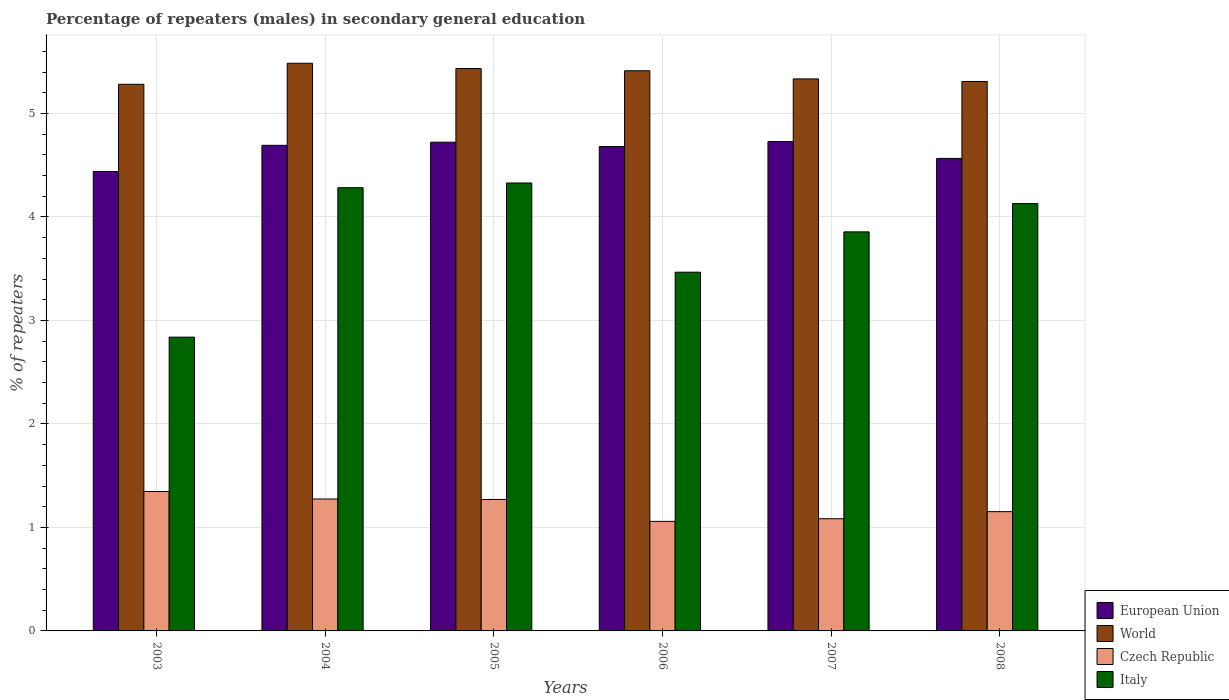Are the number of bars per tick equal to the number of legend labels?
Make the answer very short. Yes. Are the number of bars on each tick of the X-axis equal?
Your answer should be very brief. Yes. How many bars are there on the 5th tick from the left?
Provide a short and direct response. 4. In how many cases, is the number of bars for a given year not equal to the number of legend labels?
Make the answer very short. 0. What is the percentage of male repeaters in Czech Republic in 2006?
Give a very brief answer. 1.06. Across all years, what is the maximum percentage of male repeaters in Czech Republic?
Offer a very short reply. 1.35. Across all years, what is the minimum percentage of male repeaters in World?
Offer a terse response. 5.28. In which year was the percentage of male repeaters in European Union maximum?
Your answer should be compact. 2007. What is the total percentage of male repeaters in Czech Republic in the graph?
Provide a succinct answer. 7.19. What is the difference between the percentage of male repeaters in Italy in 2005 and that in 2007?
Your answer should be compact. 0.47. What is the difference between the percentage of male repeaters in World in 2005 and the percentage of male repeaters in European Union in 2006?
Your answer should be compact. 0.75. What is the average percentage of male repeaters in Czech Republic per year?
Your response must be concise. 1.2. In the year 2004, what is the difference between the percentage of male repeaters in Italy and percentage of male repeaters in European Union?
Offer a very short reply. -0.41. In how many years, is the percentage of male repeaters in European Union greater than 5.2 %?
Your response must be concise. 0. What is the ratio of the percentage of male repeaters in World in 2006 to that in 2008?
Your answer should be very brief. 1.02. Is the difference between the percentage of male repeaters in Italy in 2004 and 2008 greater than the difference between the percentage of male repeaters in European Union in 2004 and 2008?
Your response must be concise. Yes. What is the difference between the highest and the second highest percentage of male repeaters in European Union?
Ensure brevity in your answer.  0.01. What is the difference between the highest and the lowest percentage of male repeaters in European Union?
Keep it short and to the point. 0.29. Is it the case that in every year, the sum of the percentage of male repeaters in World and percentage of male repeaters in Czech Republic is greater than the sum of percentage of male repeaters in European Union and percentage of male repeaters in Italy?
Give a very brief answer. No. What does the 3rd bar from the left in 2005 represents?
Provide a succinct answer. Czech Republic. What does the 2nd bar from the right in 2004 represents?
Keep it short and to the point. Czech Republic. Is it the case that in every year, the sum of the percentage of male repeaters in World and percentage of male repeaters in Italy is greater than the percentage of male repeaters in Czech Republic?
Your answer should be very brief. Yes. Are all the bars in the graph horizontal?
Your response must be concise. No. How many years are there in the graph?
Provide a succinct answer. 6. What is the difference between two consecutive major ticks on the Y-axis?
Make the answer very short. 1. Are the values on the major ticks of Y-axis written in scientific E-notation?
Provide a succinct answer. No. Does the graph contain any zero values?
Offer a very short reply. No. How are the legend labels stacked?
Make the answer very short. Vertical. What is the title of the graph?
Your answer should be compact. Percentage of repeaters (males) in secondary general education. Does "Sudan" appear as one of the legend labels in the graph?
Keep it short and to the point. No. What is the label or title of the X-axis?
Provide a short and direct response. Years. What is the label or title of the Y-axis?
Give a very brief answer. % of repeaters. What is the % of repeaters of European Union in 2003?
Provide a short and direct response. 4.44. What is the % of repeaters of World in 2003?
Offer a terse response. 5.28. What is the % of repeaters of Czech Republic in 2003?
Give a very brief answer. 1.35. What is the % of repeaters in Italy in 2003?
Your answer should be very brief. 2.84. What is the % of repeaters in European Union in 2004?
Ensure brevity in your answer.  4.69. What is the % of repeaters of World in 2004?
Your answer should be very brief. 5.48. What is the % of repeaters of Czech Republic in 2004?
Your answer should be very brief. 1.27. What is the % of repeaters of Italy in 2004?
Provide a succinct answer. 4.28. What is the % of repeaters in European Union in 2005?
Give a very brief answer. 4.72. What is the % of repeaters in World in 2005?
Give a very brief answer. 5.43. What is the % of repeaters of Czech Republic in 2005?
Your response must be concise. 1.27. What is the % of repeaters in Italy in 2005?
Offer a very short reply. 4.33. What is the % of repeaters in European Union in 2006?
Your response must be concise. 4.68. What is the % of repeaters in World in 2006?
Your response must be concise. 5.41. What is the % of repeaters in Czech Republic in 2006?
Keep it short and to the point. 1.06. What is the % of repeaters in Italy in 2006?
Give a very brief answer. 3.47. What is the % of repeaters in European Union in 2007?
Your answer should be compact. 4.73. What is the % of repeaters of World in 2007?
Your answer should be compact. 5.33. What is the % of repeaters of Czech Republic in 2007?
Your answer should be very brief. 1.08. What is the % of repeaters of Italy in 2007?
Offer a terse response. 3.86. What is the % of repeaters in European Union in 2008?
Your response must be concise. 4.57. What is the % of repeaters of World in 2008?
Your answer should be compact. 5.31. What is the % of repeaters of Czech Republic in 2008?
Give a very brief answer. 1.15. What is the % of repeaters of Italy in 2008?
Provide a succinct answer. 4.13. Across all years, what is the maximum % of repeaters in European Union?
Make the answer very short. 4.73. Across all years, what is the maximum % of repeaters of World?
Offer a terse response. 5.48. Across all years, what is the maximum % of repeaters of Czech Republic?
Give a very brief answer. 1.35. Across all years, what is the maximum % of repeaters in Italy?
Your answer should be very brief. 4.33. Across all years, what is the minimum % of repeaters in European Union?
Make the answer very short. 4.44. Across all years, what is the minimum % of repeaters in World?
Make the answer very short. 5.28. Across all years, what is the minimum % of repeaters in Czech Republic?
Provide a short and direct response. 1.06. Across all years, what is the minimum % of repeaters of Italy?
Keep it short and to the point. 2.84. What is the total % of repeaters in European Union in the graph?
Provide a short and direct response. 27.83. What is the total % of repeaters of World in the graph?
Offer a terse response. 32.26. What is the total % of repeaters in Czech Republic in the graph?
Your response must be concise. 7.19. What is the total % of repeaters in Italy in the graph?
Give a very brief answer. 22.9. What is the difference between the % of repeaters in European Union in 2003 and that in 2004?
Make the answer very short. -0.25. What is the difference between the % of repeaters in World in 2003 and that in 2004?
Keep it short and to the point. -0.2. What is the difference between the % of repeaters in Czech Republic in 2003 and that in 2004?
Offer a terse response. 0.07. What is the difference between the % of repeaters of Italy in 2003 and that in 2004?
Your answer should be compact. -1.44. What is the difference between the % of repeaters in European Union in 2003 and that in 2005?
Provide a short and direct response. -0.28. What is the difference between the % of repeaters in World in 2003 and that in 2005?
Ensure brevity in your answer.  -0.15. What is the difference between the % of repeaters in Czech Republic in 2003 and that in 2005?
Offer a terse response. 0.08. What is the difference between the % of repeaters in Italy in 2003 and that in 2005?
Your answer should be very brief. -1.49. What is the difference between the % of repeaters in European Union in 2003 and that in 2006?
Ensure brevity in your answer.  -0.24. What is the difference between the % of repeaters of World in 2003 and that in 2006?
Ensure brevity in your answer.  -0.13. What is the difference between the % of repeaters in Czech Republic in 2003 and that in 2006?
Make the answer very short. 0.29. What is the difference between the % of repeaters in Italy in 2003 and that in 2006?
Provide a succinct answer. -0.63. What is the difference between the % of repeaters in European Union in 2003 and that in 2007?
Give a very brief answer. -0.29. What is the difference between the % of repeaters of World in 2003 and that in 2007?
Keep it short and to the point. -0.05. What is the difference between the % of repeaters in Czech Republic in 2003 and that in 2007?
Offer a very short reply. 0.26. What is the difference between the % of repeaters in Italy in 2003 and that in 2007?
Your response must be concise. -1.02. What is the difference between the % of repeaters in European Union in 2003 and that in 2008?
Provide a short and direct response. -0.13. What is the difference between the % of repeaters of World in 2003 and that in 2008?
Your answer should be compact. -0.03. What is the difference between the % of repeaters in Czech Republic in 2003 and that in 2008?
Offer a very short reply. 0.19. What is the difference between the % of repeaters of Italy in 2003 and that in 2008?
Keep it short and to the point. -1.29. What is the difference between the % of repeaters in European Union in 2004 and that in 2005?
Provide a short and direct response. -0.03. What is the difference between the % of repeaters of World in 2004 and that in 2005?
Offer a very short reply. 0.05. What is the difference between the % of repeaters of Czech Republic in 2004 and that in 2005?
Make the answer very short. 0. What is the difference between the % of repeaters of Italy in 2004 and that in 2005?
Offer a terse response. -0.05. What is the difference between the % of repeaters of European Union in 2004 and that in 2006?
Make the answer very short. 0.01. What is the difference between the % of repeaters in World in 2004 and that in 2006?
Offer a very short reply. 0.07. What is the difference between the % of repeaters in Czech Republic in 2004 and that in 2006?
Make the answer very short. 0.22. What is the difference between the % of repeaters in Italy in 2004 and that in 2006?
Make the answer very short. 0.82. What is the difference between the % of repeaters of European Union in 2004 and that in 2007?
Your answer should be compact. -0.04. What is the difference between the % of repeaters in World in 2004 and that in 2007?
Offer a very short reply. 0.15. What is the difference between the % of repeaters of Czech Republic in 2004 and that in 2007?
Your answer should be very brief. 0.19. What is the difference between the % of repeaters in Italy in 2004 and that in 2007?
Give a very brief answer. 0.43. What is the difference between the % of repeaters of European Union in 2004 and that in 2008?
Make the answer very short. 0.13. What is the difference between the % of repeaters in World in 2004 and that in 2008?
Provide a succinct answer. 0.18. What is the difference between the % of repeaters in Czech Republic in 2004 and that in 2008?
Make the answer very short. 0.12. What is the difference between the % of repeaters in Italy in 2004 and that in 2008?
Your answer should be compact. 0.15. What is the difference between the % of repeaters in European Union in 2005 and that in 2006?
Give a very brief answer. 0.04. What is the difference between the % of repeaters in World in 2005 and that in 2006?
Offer a very short reply. 0.02. What is the difference between the % of repeaters in Czech Republic in 2005 and that in 2006?
Your answer should be very brief. 0.21. What is the difference between the % of repeaters of Italy in 2005 and that in 2006?
Your answer should be very brief. 0.86. What is the difference between the % of repeaters in European Union in 2005 and that in 2007?
Provide a succinct answer. -0.01. What is the difference between the % of repeaters of World in 2005 and that in 2007?
Make the answer very short. 0.1. What is the difference between the % of repeaters of Czech Republic in 2005 and that in 2007?
Provide a short and direct response. 0.19. What is the difference between the % of repeaters of Italy in 2005 and that in 2007?
Offer a very short reply. 0.47. What is the difference between the % of repeaters in European Union in 2005 and that in 2008?
Keep it short and to the point. 0.16. What is the difference between the % of repeaters in World in 2005 and that in 2008?
Keep it short and to the point. 0.13. What is the difference between the % of repeaters in Czech Republic in 2005 and that in 2008?
Offer a terse response. 0.12. What is the difference between the % of repeaters of Italy in 2005 and that in 2008?
Keep it short and to the point. 0.2. What is the difference between the % of repeaters of European Union in 2006 and that in 2007?
Your response must be concise. -0.05. What is the difference between the % of repeaters in World in 2006 and that in 2007?
Offer a terse response. 0.08. What is the difference between the % of repeaters in Czech Republic in 2006 and that in 2007?
Your answer should be compact. -0.03. What is the difference between the % of repeaters in Italy in 2006 and that in 2007?
Provide a succinct answer. -0.39. What is the difference between the % of repeaters of European Union in 2006 and that in 2008?
Your answer should be compact. 0.11. What is the difference between the % of repeaters in World in 2006 and that in 2008?
Give a very brief answer. 0.1. What is the difference between the % of repeaters of Czech Republic in 2006 and that in 2008?
Your response must be concise. -0.09. What is the difference between the % of repeaters in Italy in 2006 and that in 2008?
Your answer should be compact. -0.66. What is the difference between the % of repeaters of European Union in 2007 and that in 2008?
Your answer should be compact. 0.16. What is the difference between the % of repeaters in World in 2007 and that in 2008?
Offer a terse response. 0.03. What is the difference between the % of repeaters of Czech Republic in 2007 and that in 2008?
Your response must be concise. -0.07. What is the difference between the % of repeaters in Italy in 2007 and that in 2008?
Provide a short and direct response. -0.27. What is the difference between the % of repeaters in European Union in 2003 and the % of repeaters in World in 2004?
Give a very brief answer. -1.05. What is the difference between the % of repeaters in European Union in 2003 and the % of repeaters in Czech Republic in 2004?
Provide a short and direct response. 3.16. What is the difference between the % of repeaters of European Union in 2003 and the % of repeaters of Italy in 2004?
Make the answer very short. 0.16. What is the difference between the % of repeaters in World in 2003 and the % of repeaters in Czech Republic in 2004?
Provide a succinct answer. 4.01. What is the difference between the % of repeaters in World in 2003 and the % of repeaters in Italy in 2004?
Offer a terse response. 1. What is the difference between the % of repeaters of Czech Republic in 2003 and the % of repeaters of Italy in 2004?
Ensure brevity in your answer.  -2.94. What is the difference between the % of repeaters in European Union in 2003 and the % of repeaters in World in 2005?
Provide a short and direct response. -1. What is the difference between the % of repeaters in European Union in 2003 and the % of repeaters in Czech Republic in 2005?
Ensure brevity in your answer.  3.17. What is the difference between the % of repeaters in European Union in 2003 and the % of repeaters in Italy in 2005?
Your answer should be compact. 0.11. What is the difference between the % of repeaters of World in 2003 and the % of repeaters of Czech Republic in 2005?
Provide a succinct answer. 4.01. What is the difference between the % of repeaters in World in 2003 and the % of repeaters in Italy in 2005?
Your answer should be very brief. 0.95. What is the difference between the % of repeaters in Czech Republic in 2003 and the % of repeaters in Italy in 2005?
Provide a succinct answer. -2.98. What is the difference between the % of repeaters of European Union in 2003 and the % of repeaters of World in 2006?
Offer a very short reply. -0.97. What is the difference between the % of repeaters in European Union in 2003 and the % of repeaters in Czech Republic in 2006?
Give a very brief answer. 3.38. What is the difference between the % of repeaters in European Union in 2003 and the % of repeaters in Italy in 2006?
Your answer should be compact. 0.97. What is the difference between the % of repeaters of World in 2003 and the % of repeaters of Czech Republic in 2006?
Offer a terse response. 4.22. What is the difference between the % of repeaters of World in 2003 and the % of repeaters of Italy in 2006?
Your answer should be very brief. 1.82. What is the difference between the % of repeaters of Czech Republic in 2003 and the % of repeaters of Italy in 2006?
Your answer should be very brief. -2.12. What is the difference between the % of repeaters of European Union in 2003 and the % of repeaters of World in 2007?
Provide a short and direct response. -0.89. What is the difference between the % of repeaters of European Union in 2003 and the % of repeaters of Czech Republic in 2007?
Your response must be concise. 3.35. What is the difference between the % of repeaters of European Union in 2003 and the % of repeaters of Italy in 2007?
Give a very brief answer. 0.58. What is the difference between the % of repeaters of World in 2003 and the % of repeaters of Czech Republic in 2007?
Your answer should be very brief. 4.2. What is the difference between the % of repeaters of World in 2003 and the % of repeaters of Italy in 2007?
Your response must be concise. 1.43. What is the difference between the % of repeaters in Czech Republic in 2003 and the % of repeaters in Italy in 2007?
Provide a short and direct response. -2.51. What is the difference between the % of repeaters of European Union in 2003 and the % of repeaters of World in 2008?
Your answer should be compact. -0.87. What is the difference between the % of repeaters in European Union in 2003 and the % of repeaters in Czech Republic in 2008?
Give a very brief answer. 3.29. What is the difference between the % of repeaters of European Union in 2003 and the % of repeaters of Italy in 2008?
Offer a very short reply. 0.31. What is the difference between the % of repeaters in World in 2003 and the % of repeaters in Czech Republic in 2008?
Offer a terse response. 4.13. What is the difference between the % of repeaters in World in 2003 and the % of repeaters in Italy in 2008?
Make the answer very short. 1.15. What is the difference between the % of repeaters of Czech Republic in 2003 and the % of repeaters of Italy in 2008?
Your answer should be very brief. -2.78. What is the difference between the % of repeaters of European Union in 2004 and the % of repeaters of World in 2005?
Keep it short and to the point. -0.74. What is the difference between the % of repeaters of European Union in 2004 and the % of repeaters of Czech Republic in 2005?
Provide a succinct answer. 3.42. What is the difference between the % of repeaters in European Union in 2004 and the % of repeaters in Italy in 2005?
Provide a succinct answer. 0.36. What is the difference between the % of repeaters in World in 2004 and the % of repeaters in Czech Republic in 2005?
Ensure brevity in your answer.  4.21. What is the difference between the % of repeaters in World in 2004 and the % of repeaters in Italy in 2005?
Your answer should be compact. 1.16. What is the difference between the % of repeaters of Czech Republic in 2004 and the % of repeaters of Italy in 2005?
Provide a succinct answer. -3.05. What is the difference between the % of repeaters of European Union in 2004 and the % of repeaters of World in 2006?
Your answer should be very brief. -0.72. What is the difference between the % of repeaters of European Union in 2004 and the % of repeaters of Czech Republic in 2006?
Ensure brevity in your answer.  3.63. What is the difference between the % of repeaters in European Union in 2004 and the % of repeaters in Italy in 2006?
Keep it short and to the point. 1.23. What is the difference between the % of repeaters of World in 2004 and the % of repeaters of Czech Republic in 2006?
Your answer should be compact. 4.43. What is the difference between the % of repeaters of World in 2004 and the % of repeaters of Italy in 2006?
Give a very brief answer. 2.02. What is the difference between the % of repeaters of Czech Republic in 2004 and the % of repeaters of Italy in 2006?
Your response must be concise. -2.19. What is the difference between the % of repeaters of European Union in 2004 and the % of repeaters of World in 2007?
Give a very brief answer. -0.64. What is the difference between the % of repeaters of European Union in 2004 and the % of repeaters of Czech Republic in 2007?
Offer a terse response. 3.61. What is the difference between the % of repeaters in European Union in 2004 and the % of repeaters in Italy in 2007?
Give a very brief answer. 0.84. What is the difference between the % of repeaters of World in 2004 and the % of repeaters of Czech Republic in 2007?
Your answer should be compact. 4.4. What is the difference between the % of repeaters in World in 2004 and the % of repeaters in Italy in 2007?
Provide a short and direct response. 1.63. What is the difference between the % of repeaters of Czech Republic in 2004 and the % of repeaters of Italy in 2007?
Keep it short and to the point. -2.58. What is the difference between the % of repeaters of European Union in 2004 and the % of repeaters of World in 2008?
Offer a very short reply. -0.62. What is the difference between the % of repeaters of European Union in 2004 and the % of repeaters of Czech Republic in 2008?
Make the answer very short. 3.54. What is the difference between the % of repeaters of European Union in 2004 and the % of repeaters of Italy in 2008?
Provide a succinct answer. 0.56. What is the difference between the % of repeaters in World in 2004 and the % of repeaters in Czech Republic in 2008?
Keep it short and to the point. 4.33. What is the difference between the % of repeaters in World in 2004 and the % of repeaters in Italy in 2008?
Keep it short and to the point. 1.36. What is the difference between the % of repeaters in Czech Republic in 2004 and the % of repeaters in Italy in 2008?
Ensure brevity in your answer.  -2.85. What is the difference between the % of repeaters of European Union in 2005 and the % of repeaters of World in 2006?
Provide a succinct answer. -0.69. What is the difference between the % of repeaters of European Union in 2005 and the % of repeaters of Czech Republic in 2006?
Ensure brevity in your answer.  3.66. What is the difference between the % of repeaters of European Union in 2005 and the % of repeaters of Italy in 2006?
Offer a very short reply. 1.26. What is the difference between the % of repeaters in World in 2005 and the % of repeaters in Czech Republic in 2006?
Make the answer very short. 4.38. What is the difference between the % of repeaters of World in 2005 and the % of repeaters of Italy in 2006?
Ensure brevity in your answer.  1.97. What is the difference between the % of repeaters of Czech Republic in 2005 and the % of repeaters of Italy in 2006?
Provide a short and direct response. -2.2. What is the difference between the % of repeaters of European Union in 2005 and the % of repeaters of World in 2007?
Make the answer very short. -0.61. What is the difference between the % of repeaters of European Union in 2005 and the % of repeaters of Czech Republic in 2007?
Make the answer very short. 3.64. What is the difference between the % of repeaters of European Union in 2005 and the % of repeaters of Italy in 2007?
Offer a terse response. 0.87. What is the difference between the % of repeaters in World in 2005 and the % of repeaters in Czech Republic in 2007?
Provide a short and direct response. 4.35. What is the difference between the % of repeaters in World in 2005 and the % of repeaters in Italy in 2007?
Your answer should be very brief. 1.58. What is the difference between the % of repeaters in Czech Republic in 2005 and the % of repeaters in Italy in 2007?
Give a very brief answer. -2.59. What is the difference between the % of repeaters of European Union in 2005 and the % of repeaters of World in 2008?
Make the answer very short. -0.59. What is the difference between the % of repeaters of European Union in 2005 and the % of repeaters of Czech Republic in 2008?
Provide a succinct answer. 3.57. What is the difference between the % of repeaters in European Union in 2005 and the % of repeaters in Italy in 2008?
Your response must be concise. 0.59. What is the difference between the % of repeaters of World in 2005 and the % of repeaters of Czech Republic in 2008?
Give a very brief answer. 4.28. What is the difference between the % of repeaters in World in 2005 and the % of repeaters in Italy in 2008?
Offer a terse response. 1.31. What is the difference between the % of repeaters in Czech Republic in 2005 and the % of repeaters in Italy in 2008?
Ensure brevity in your answer.  -2.86. What is the difference between the % of repeaters in European Union in 2006 and the % of repeaters in World in 2007?
Provide a succinct answer. -0.65. What is the difference between the % of repeaters in European Union in 2006 and the % of repeaters in Czech Republic in 2007?
Your answer should be very brief. 3.6. What is the difference between the % of repeaters in European Union in 2006 and the % of repeaters in Italy in 2007?
Ensure brevity in your answer.  0.82. What is the difference between the % of repeaters in World in 2006 and the % of repeaters in Czech Republic in 2007?
Provide a short and direct response. 4.33. What is the difference between the % of repeaters of World in 2006 and the % of repeaters of Italy in 2007?
Provide a succinct answer. 1.56. What is the difference between the % of repeaters in Czech Republic in 2006 and the % of repeaters in Italy in 2007?
Keep it short and to the point. -2.8. What is the difference between the % of repeaters of European Union in 2006 and the % of repeaters of World in 2008?
Ensure brevity in your answer.  -0.63. What is the difference between the % of repeaters of European Union in 2006 and the % of repeaters of Czech Republic in 2008?
Make the answer very short. 3.53. What is the difference between the % of repeaters of European Union in 2006 and the % of repeaters of Italy in 2008?
Ensure brevity in your answer.  0.55. What is the difference between the % of repeaters of World in 2006 and the % of repeaters of Czech Republic in 2008?
Keep it short and to the point. 4.26. What is the difference between the % of repeaters in World in 2006 and the % of repeaters in Italy in 2008?
Provide a short and direct response. 1.28. What is the difference between the % of repeaters of Czech Republic in 2006 and the % of repeaters of Italy in 2008?
Your answer should be compact. -3.07. What is the difference between the % of repeaters of European Union in 2007 and the % of repeaters of World in 2008?
Make the answer very short. -0.58. What is the difference between the % of repeaters in European Union in 2007 and the % of repeaters in Czech Republic in 2008?
Ensure brevity in your answer.  3.58. What is the difference between the % of repeaters in European Union in 2007 and the % of repeaters in Italy in 2008?
Your answer should be compact. 0.6. What is the difference between the % of repeaters of World in 2007 and the % of repeaters of Czech Republic in 2008?
Provide a succinct answer. 4.18. What is the difference between the % of repeaters of World in 2007 and the % of repeaters of Italy in 2008?
Offer a very short reply. 1.2. What is the difference between the % of repeaters of Czech Republic in 2007 and the % of repeaters of Italy in 2008?
Offer a terse response. -3.04. What is the average % of repeaters in European Union per year?
Keep it short and to the point. 4.64. What is the average % of repeaters of World per year?
Offer a very short reply. 5.38. What is the average % of repeaters in Czech Republic per year?
Offer a terse response. 1.2. What is the average % of repeaters of Italy per year?
Your response must be concise. 3.82. In the year 2003, what is the difference between the % of repeaters in European Union and % of repeaters in World?
Keep it short and to the point. -0.84. In the year 2003, what is the difference between the % of repeaters in European Union and % of repeaters in Czech Republic?
Give a very brief answer. 3.09. In the year 2003, what is the difference between the % of repeaters in European Union and % of repeaters in Italy?
Offer a terse response. 1.6. In the year 2003, what is the difference between the % of repeaters in World and % of repeaters in Czech Republic?
Give a very brief answer. 3.93. In the year 2003, what is the difference between the % of repeaters in World and % of repeaters in Italy?
Give a very brief answer. 2.44. In the year 2003, what is the difference between the % of repeaters in Czech Republic and % of repeaters in Italy?
Give a very brief answer. -1.49. In the year 2004, what is the difference between the % of repeaters of European Union and % of repeaters of World?
Keep it short and to the point. -0.79. In the year 2004, what is the difference between the % of repeaters in European Union and % of repeaters in Czech Republic?
Offer a terse response. 3.42. In the year 2004, what is the difference between the % of repeaters in European Union and % of repeaters in Italy?
Offer a very short reply. 0.41. In the year 2004, what is the difference between the % of repeaters in World and % of repeaters in Czech Republic?
Offer a terse response. 4.21. In the year 2004, what is the difference between the % of repeaters of World and % of repeaters of Italy?
Make the answer very short. 1.2. In the year 2004, what is the difference between the % of repeaters in Czech Republic and % of repeaters in Italy?
Offer a very short reply. -3.01. In the year 2005, what is the difference between the % of repeaters in European Union and % of repeaters in World?
Give a very brief answer. -0.71. In the year 2005, what is the difference between the % of repeaters in European Union and % of repeaters in Czech Republic?
Ensure brevity in your answer.  3.45. In the year 2005, what is the difference between the % of repeaters of European Union and % of repeaters of Italy?
Offer a very short reply. 0.39. In the year 2005, what is the difference between the % of repeaters in World and % of repeaters in Czech Republic?
Make the answer very short. 4.16. In the year 2005, what is the difference between the % of repeaters in World and % of repeaters in Italy?
Your answer should be very brief. 1.11. In the year 2005, what is the difference between the % of repeaters of Czech Republic and % of repeaters of Italy?
Give a very brief answer. -3.06. In the year 2006, what is the difference between the % of repeaters in European Union and % of repeaters in World?
Offer a terse response. -0.73. In the year 2006, what is the difference between the % of repeaters of European Union and % of repeaters of Czech Republic?
Offer a terse response. 3.62. In the year 2006, what is the difference between the % of repeaters of European Union and % of repeaters of Italy?
Your answer should be very brief. 1.21. In the year 2006, what is the difference between the % of repeaters in World and % of repeaters in Czech Republic?
Make the answer very short. 4.35. In the year 2006, what is the difference between the % of repeaters in World and % of repeaters in Italy?
Make the answer very short. 1.95. In the year 2006, what is the difference between the % of repeaters of Czech Republic and % of repeaters of Italy?
Ensure brevity in your answer.  -2.41. In the year 2007, what is the difference between the % of repeaters in European Union and % of repeaters in World?
Your response must be concise. -0.61. In the year 2007, what is the difference between the % of repeaters of European Union and % of repeaters of Czech Republic?
Provide a succinct answer. 3.64. In the year 2007, what is the difference between the % of repeaters in European Union and % of repeaters in Italy?
Your response must be concise. 0.87. In the year 2007, what is the difference between the % of repeaters of World and % of repeaters of Czech Republic?
Give a very brief answer. 4.25. In the year 2007, what is the difference between the % of repeaters in World and % of repeaters in Italy?
Offer a terse response. 1.48. In the year 2007, what is the difference between the % of repeaters of Czech Republic and % of repeaters of Italy?
Make the answer very short. -2.77. In the year 2008, what is the difference between the % of repeaters of European Union and % of repeaters of World?
Your answer should be compact. -0.74. In the year 2008, what is the difference between the % of repeaters in European Union and % of repeaters in Czech Republic?
Provide a short and direct response. 3.41. In the year 2008, what is the difference between the % of repeaters of European Union and % of repeaters of Italy?
Your response must be concise. 0.44. In the year 2008, what is the difference between the % of repeaters in World and % of repeaters in Czech Republic?
Offer a terse response. 4.16. In the year 2008, what is the difference between the % of repeaters of World and % of repeaters of Italy?
Your response must be concise. 1.18. In the year 2008, what is the difference between the % of repeaters in Czech Republic and % of repeaters in Italy?
Keep it short and to the point. -2.98. What is the ratio of the % of repeaters of European Union in 2003 to that in 2004?
Keep it short and to the point. 0.95. What is the ratio of the % of repeaters of World in 2003 to that in 2004?
Your answer should be very brief. 0.96. What is the ratio of the % of repeaters of Czech Republic in 2003 to that in 2004?
Your answer should be very brief. 1.06. What is the ratio of the % of repeaters in Italy in 2003 to that in 2004?
Keep it short and to the point. 0.66. What is the ratio of the % of repeaters of European Union in 2003 to that in 2005?
Provide a short and direct response. 0.94. What is the ratio of the % of repeaters in World in 2003 to that in 2005?
Keep it short and to the point. 0.97. What is the ratio of the % of repeaters of Czech Republic in 2003 to that in 2005?
Offer a very short reply. 1.06. What is the ratio of the % of repeaters in Italy in 2003 to that in 2005?
Give a very brief answer. 0.66. What is the ratio of the % of repeaters of European Union in 2003 to that in 2006?
Provide a short and direct response. 0.95. What is the ratio of the % of repeaters of World in 2003 to that in 2006?
Your answer should be very brief. 0.98. What is the ratio of the % of repeaters of Czech Republic in 2003 to that in 2006?
Your response must be concise. 1.27. What is the ratio of the % of repeaters of Italy in 2003 to that in 2006?
Provide a short and direct response. 0.82. What is the ratio of the % of repeaters of European Union in 2003 to that in 2007?
Ensure brevity in your answer.  0.94. What is the ratio of the % of repeaters in World in 2003 to that in 2007?
Your response must be concise. 0.99. What is the ratio of the % of repeaters in Czech Republic in 2003 to that in 2007?
Provide a succinct answer. 1.24. What is the ratio of the % of repeaters in Italy in 2003 to that in 2007?
Your answer should be very brief. 0.74. What is the ratio of the % of repeaters of European Union in 2003 to that in 2008?
Ensure brevity in your answer.  0.97. What is the ratio of the % of repeaters of Czech Republic in 2003 to that in 2008?
Offer a very short reply. 1.17. What is the ratio of the % of repeaters of Italy in 2003 to that in 2008?
Your answer should be very brief. 0.69. What is the ratio of the % of repeaters of European Union in 2004 to that in 2005?
Make the answer very short. 0.99. What is the ratio of the % of repeaters in World in 2004 to that in 2005?
Ensure brevity in your answer.  1.01. What is the ratio of the % of repeaters of Italy in 2004 to that in 2005?
Ensure brevity in your answer.  0.99. What is the ratio of the % of repeaters of World in 2004 to that in 2006?
Your answer should be compact. 1.01. What is the ratio of the % of repeaters of Czech Republic in 2004 to that in 2006?
Keep it short and to the point. 1.2. What is the ratio of the % of repeaters of Italy in 2004 to that in 2006?
Provide a succinct answer. 1.24. What is the ratio of the % of repeaters in World in 2004 to that in 2007?
Offer a very short reply. 1.03. What is the ratio of the % of repeaters in Czech Republic in 2004 to that in 2007?
Your answer should be very brief. 1.18. What is the ratio of the % of repeaters in Italy in 2004 to that in 2007?
Your answer should be very brief. 1.11. What is the ratio of the % of repeaters of European Union in 2004 to that in 2008?
Provide a succinct answer. 1.03. What is the ratio of the % of repeaters of World in 2004 to that in 2008?
Ensure brevity in your answer.  1.03. What is the ratio of the % of repeaters in Czech Republic in 2004 to that in 2008?
Give a very brief answer. 1.11. What is the ratio of the % of repeaters of Italy in 2004 to that in 2008?
Keep it short and to the point. 1.04. What is the ratio of the % of repeaters in European Union in 2005 to that in 2006?
Offer a terse response. 1.01. What is the ratio of the % of repeaters in World in 2005 to that in 2006?
Your answer should be compact. 1. What is the ratio of the % of repeaters in Czech Republic in 2005 to that in 2006?
Provide a succinct answer. 1.2. What is the ratio of the % of repeaters of Italy in 2005 to that in 2006?
Give a very brief answer. 1.25. What is the ratio of the % of repeaters of World in 2005 to that in 2007?
Your answer should be very brief. 1.02. What is the ratio of the % of repeaters in Czech Republic in 2005 to that in 2007?
Keep it short and to the point. 1.17. What is the ratio of the % of repeaters of Italy in 2005 to that in 2007?
Ensure brevity in your answer.  1.12. What is the ratio of the % of repeaters of European Union in 2005 to that in 2008?
Offer a very short reply. 1.03. What is the ratio of the % of repeaters in World in 2005 to that in 2008?
Your answer should be compact. 1.02. What is the ratio of the % of repeaters of Czech Republic in 2005 to that in 2008?
Ensure brevity in your answer.  1.1. What is the ratio of the % of repeaters of Italy in 2005 to that in 2008?
Give a very brief answer. 1.05. What is the ratio of the % of repeaters of World in 2006 to that in 2007?
Keep it short and to the point. 1.01. What is the ratio of the % of repeaters in Czech Republic in 2006 to that in 2007?
Offer a very short reply. 0.98. What is the ratio of the % of repeaters in Italy in 2006 to that in 2007?
Provide a short and direct response. 0.9. What is the ratio of the % of repeaters of European Union in 2006 to that in 2008?
Your answer should be very brief. 1.03. What is the ratio of the % of repeaters in World in 2006 to that in 2008?
Provide a short and direct response. 1.02. What is the ratio of the % of repeaters in Czech Republic in 2006 to that in 2008?
Your answer should be very brief. 0.92. What is the ratio of the % of repeaters in Italy in 2006 to that in 2008?
Ensure brevity in your answer.  0.84. What is the ratio of the % of repeaters in European Union in 2007 to that in 2008?
Offer a very short reply. 1.04. What is the ratio of the % of repeaters of Czech Republic in 2007 to that in 2008?
Offer a terse response. 0.94. What is the ratio of the % of repeaters in Italy in 2007 to that in 2008?
Provide a short and direct response. 0.93. What is the difference between the highest and the second highest % of repeaters in European Union?
Your answer should be very brief. 0.01. What is the difference between the highest and the second highest % of repeaters in World?
Ensure brevity in your answer.  0.05. What is the difference between the highest and the second highest % of repeaters of Czech Republic?
Offer a very short reply. 0.07. What is the difference between the highest and the second highest % of repeaters in Italy?
Give a very brief answer. 0.05. What is the difference between the highest and the lowest % of repeaters of European Union?
Your answer should be very brief. 0.29. What is the difference between the highest and the lowest % of repeaters in World?
Your response must be concise. 0.2. What is the difference between the highest and the lowest % of repeaters in Czech Republic?
Offer a very short reply. 0.29. What is the difference between the highest and the lowest % of repeaters of Italy?
Provide a succinct answer. 1.49. 